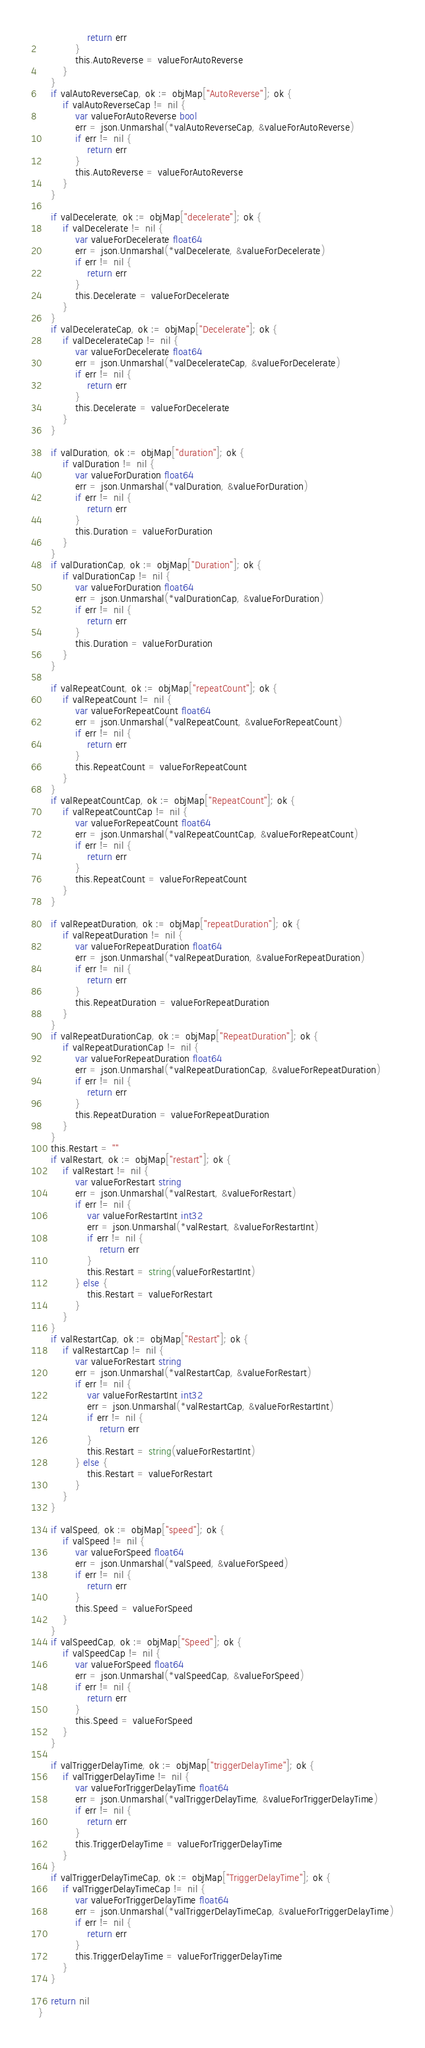<code> <loc_0><loc_0><loc_500><loc_500><_Go_>				return err
			}
			this.AutoReverse = valueForAutoReverse
		}
	}
	if valAutoReverseCap, ok := objMap["AutoReverse"]; ok {
		if valAutoReverseCap != nil {
			var valueForAutoReverse bool
			err = json.Unmarshal(*valAutoReverseCap, &valueForAutoReverse)
			if err != nil {
				return err
			}
			this.AutoReverse = valueForAutoReverse
		}
	}
	
	if valDecelerate, ok := objMap["decelerate"]; ok {
		if valDecelerate != nil {
			var valueForDecelerate float64
			err = json.Unmarshal(*valDecelerate, &valueForDecelerate)
			if err != nil {
				return err
			}
			this.Decelerate = valueForDecelerate
		}
	}
	if valDecelerateCap, ok := objMap["Decelerate"]; ok {
		if valDecelerateCap != nil {
			var valueForDecelerate float64
			err = json.Unmarshal(*valDecelerateCap, &valueForDecelerate)
			if err != nil {
				return err
			}
			this.Decelerate = valueForDecelerate
		}
	}
	
	if valDuration, ok := objMap["duration"]; ok {
		if valDuration != nil {
			var valueForDuration float64
			err = json.Unmarshal(*valDuration, &valueForDuration)
			if err != nil {
				return err
			}
			this.Duration = valueForDuration
		}
	}
	if valDurationCap, ok := objMap["Duration"]; ok {
		if valDurationCap != nil {
			var valueForDuration float64
			err = json.Unmarshal(*valDurationCap, &valueForDuration)
			if err != nil {
				return err
			}
			this.Duration = valueForDuration
		}
	}
	
	if valRepeatCount, ok := objMap["repeatCount"]; ok {
		if valRepeatCount != nil {
			var valueForRepeatCount float64
			err = json.Unmarshal(*valRepeatCount, &valueForRepeatCount)
			if err != nil {
				return err
			}
			this.RepeatCount = valueForRepeatCount
		}
	}
	if valRepeatCountCap, ok := objMap["RepeatCount"]; ok {
		if valRepeatCountCap != nil {
			var valueForRepeatCount float64
			err = json.Unmarshal(*valRepeatCountCap, &valueForRepeatCount)
			if err != nil {
				return err
			}
			this.RepeatCount = valueForRepeatCount
		}
	}
	
	if valRepeatDuration, ok := objMap["repeatDuration"]; ok {
		if valRepeatDuration != nil {
			var valueForRepeatDuration float64
			err = json.Unmarshal(*valRepeatDuration, &valueForRepeatDuration)
			if err != nil {
				return err
			}
			this.RepeatDuration = valueForRepeatDuration
		}
	}
	if valRepeatDurationCap, ok := objMap["RepeatDuration"]; ok {
		if valRepeatDurationCap != nil {
			var valueForRepeatDuration float64
			err = json.Unmarshal(*valRepeatDurationCap, &valueForRepeatDuration)
			if err != nil {
				return err
			}
			this.RepeatDuration = valueForRepeatDuration
		}
	}
	this.Restart = ""
	if valRestart, ok := objMap["restart"]; ok {
		if valRestart != nil {
			var valueForRestart string
			err = json.Unmarshal(*valRestart, &valueForRestart)
			if err != nil {
				var valueForRestartInt int32
				err = json.Unmarshal(*valRestart, &valueForRestartInt)
				if err != nil {
					return err
				}
				this.Restart = string(valueForRestartInt)
			} else {
				this.Restart = valueForRestart
			}
		}
	}
	if valRestartCap, ok := objMap["Restart"]; ok {
		if valRestartCap != nil {
			var valueForRestart string
			err = json.Unmarshal(*valRestartCap, &valueForRestart)
			if err != nil {
				var valueForRestartInt int32
				err = json.Unmarshal(*valRestartCap, &valueForRestartInt)
				if err != nil {
					return err
				}
				this.Restart = string(valueForRestartInt)
			} else {
				this.Restart = valueForRestart
			}
		}
	}
	
	if valSpeed, ok := objMap["speed"]; ok {
		if valSpeed != nil {
			var valueForSpeed float64
			err = json.Unmarshal(*valSpeed, &valueForSpeed)
			if err != nil {
				return err
			}
			this.Speed = valueForSpeed
		}
	}
	if valSpeedCap, ok := objMap["Speed"]; ok {
		if valSpeedCap != nil {
			var valueForSpeed float64
			err = json.Unmarshal(*valSpeedCap, &valueForSpeed)
			if err != nil {
				return err
			}
			this.Speed = valueForSpeed
		}
	}
	
	if valTriggerDelayTime, ok := objMap["triggerDelayTime"]; ok {
		if valTriggerDelayTime != nil {
			var valueForTriggerDelayTime float64
			err = json.Unmarshal(*valTriggerDelayTime, &valueForTriggerDelayTime)
			if err != nil {
				return err
			}
			this.TriggerDelayTime = valueForTriggerDelayTime
		}
	}
	if valTriggerDelayTimeCap, ok := objMap["TriggerDelayTime"]; ok {
		if valTriggerDelayTimeCap != nil {
			var valueForTriggerDelayTime float64
			err = json.Unmarshal(*valTriggerDelayTimeCap, &valueForTriggerDelayTime)
			if err != nil {
				return err
			}
			this.TriggerDelayTime = valueForTriggerDelayTime
		}
	}

    return nil
}
</code> 